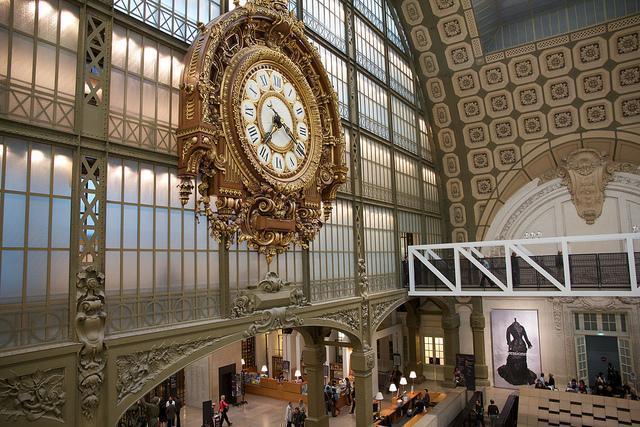What is on the advertisement overlooked by the gold clock?
Answer the question by selecting the correct answer among the 4 following choices and explain your choice with a short sentence. The answer should be formatted with the following format: `Answer: choice
Rationale: rationale.`
Options: Watch, dress, food, perfume. Answer: dress.
Rationale: A silhoutte of an outfit. 